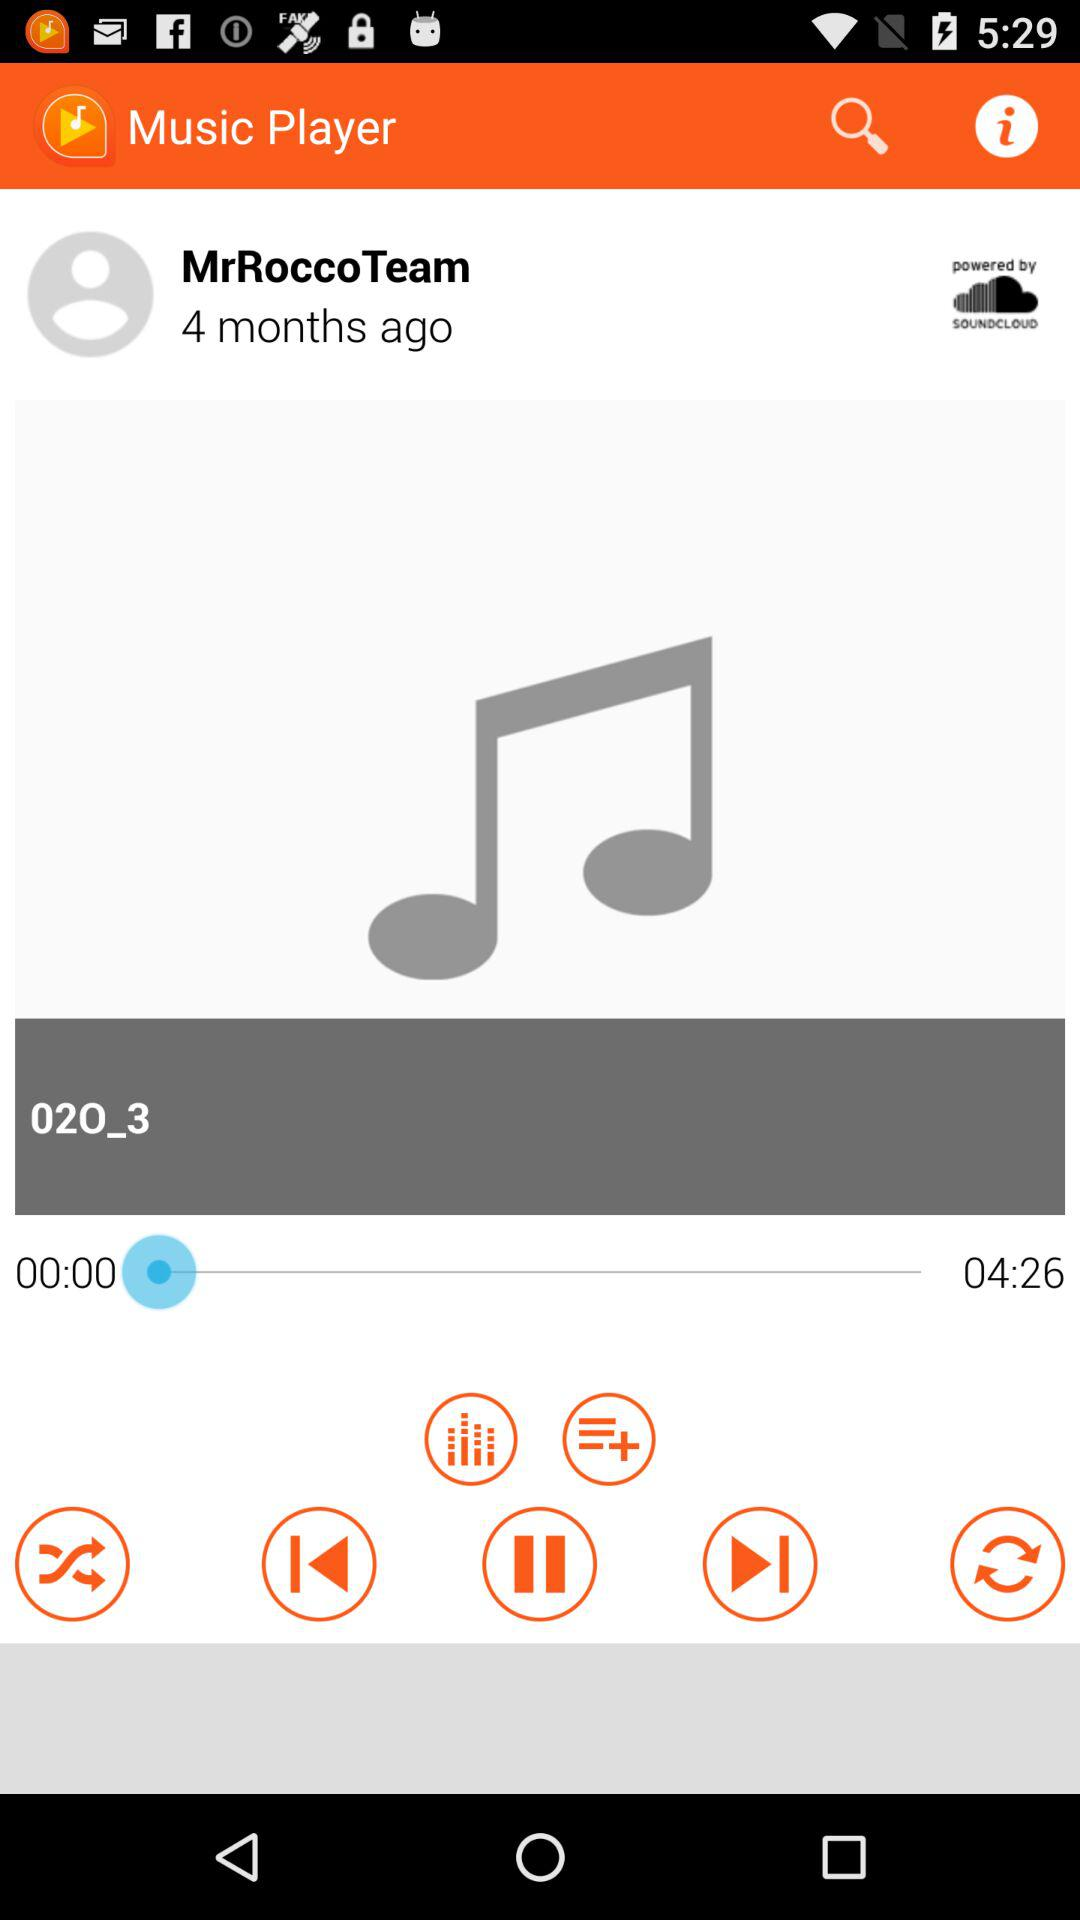How many months ago the song was released? The song was released 4 months ago. 